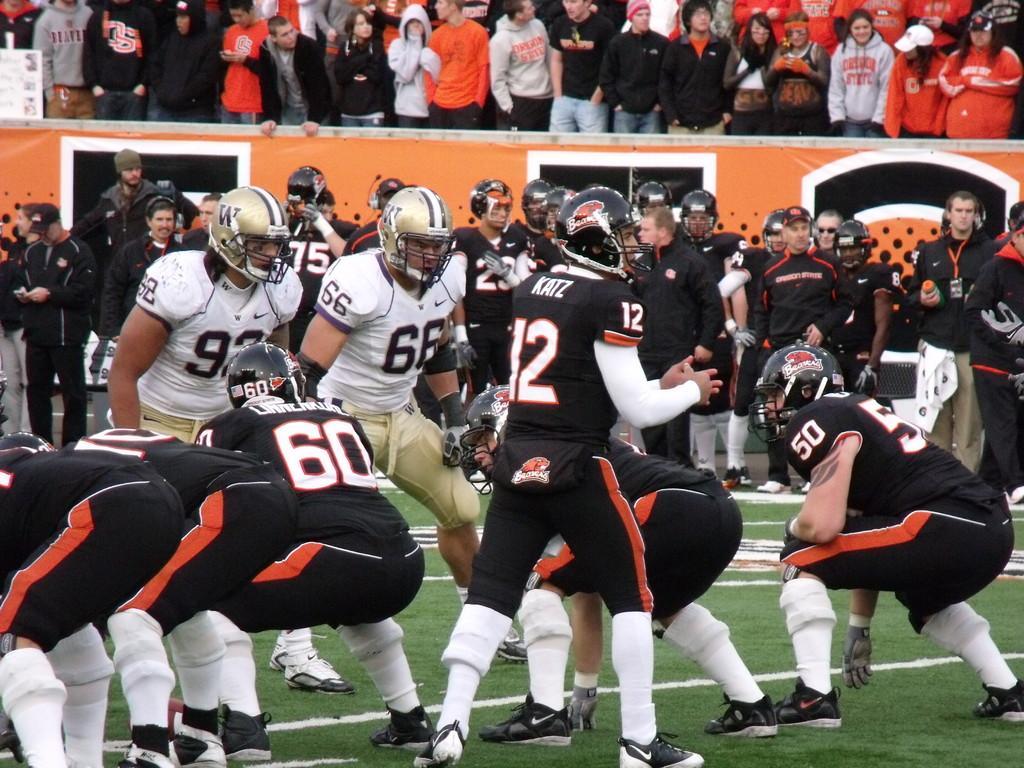In one or two sentences, can you explain what this image depicts? In this picture we can see some are playing matches on the ground, back side so many people are watching the match. 